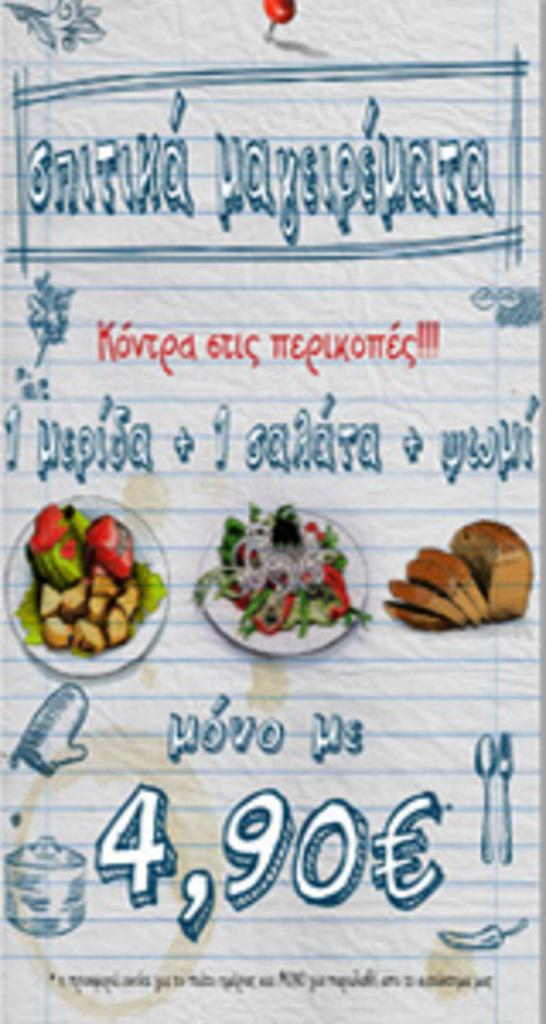What is the main object in the image? There is a paper in the image. What can be found on the paper? The paper contains text and pictures of food items. Is there any numerical information visible in the image? Yes, there is a number visible in the image. What type of cannon is being used to attack the beggar in the image? There is no cannon or beggar present in the image; it only contains a paper with text and pictures of food items. 